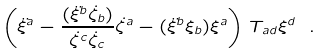<formula> <loc_0><loc_0><loc_500><loc_500>\left ( \ddot { \xi } ^ { a } - \frac { ( \ddot { \xi } ^ { b } \dot { \zeta } _ { b } ) } { \dot { \zeta } ^ { c } \dot { \zeta } _ { c } } \dot { \zeta } ^ { a } - ( \ddot { \xi } ^ { b } \xi _ { b } ) \xi ^ { a } \right ) T _ { a d } \xi ^ { d } \ .</formula> 